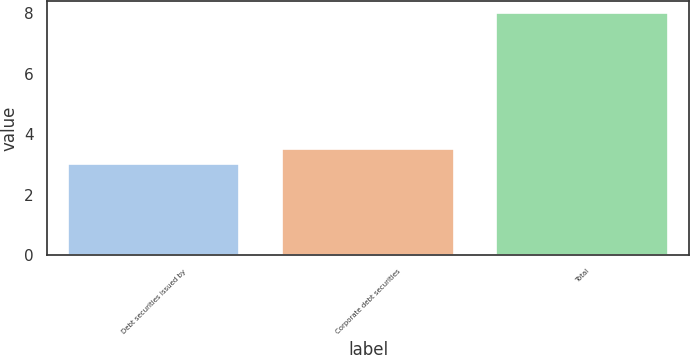Convert chart. <chart><loc_0><loc_0><loc_500><loc_500><bar_chart><fcel>Debt securities issued by<fcel>Corporate debt securities<fcel>Total<nl><fcel>3<fcel>3.5<fcel>8<nl></chart> 